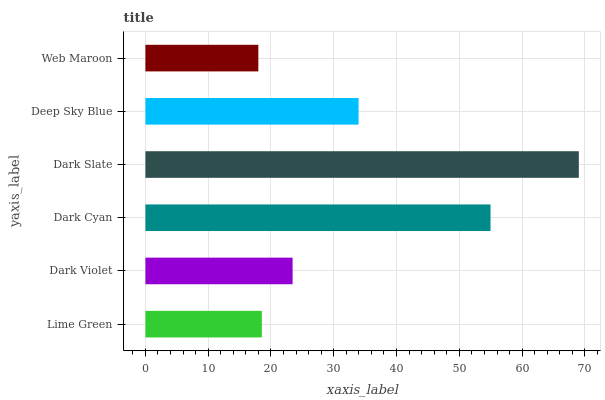Is Web Maroon the minimum?
Answer yes or no. Yes. Is Dark Slate the maximum?
Answer yes or no. Yes. Is Dark Violet the minimum?
Answer yes or no. No. Is Dark Violet the maximum?
Answer yes or no. No. Is Dark Violet greater than Lime Green?
Answer yes or no. Yes. Is Lime Green less than Dark Violet?
Answer yes or no. Yes. Is Lime Green greater than Dark Violet?
Answer yes or no. No. Is Dark Violet less than Lime Green?
Answer yes or no. No. Is Deep Sky Blue the high median?
Answer yes or no. Yes. Is Dark Violet the low median?
Answer yes or no. Yes. Is Dark Violet the high median?
Answer yes or no. No. Is Dark Slate the low median?
Answer yes or no. No. 